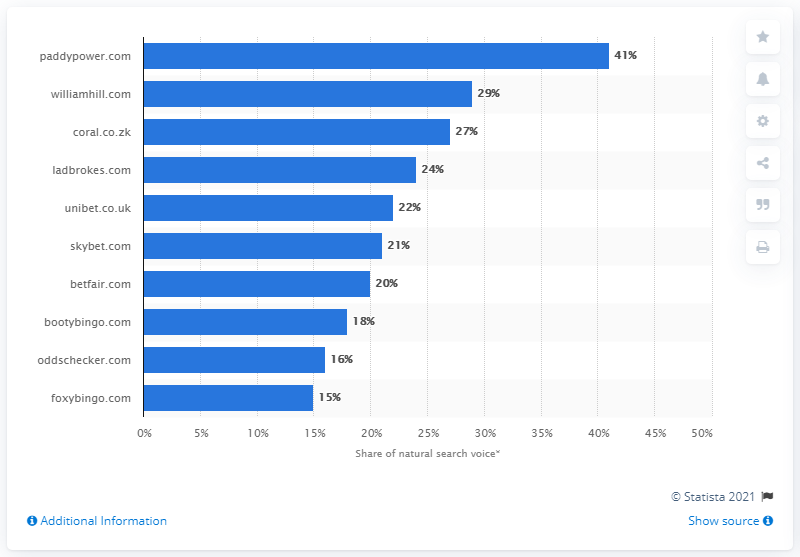Highlight a few significant elements in this photo. According to a natural search in March 2016, paddypower.com had a share of 41 percent. 